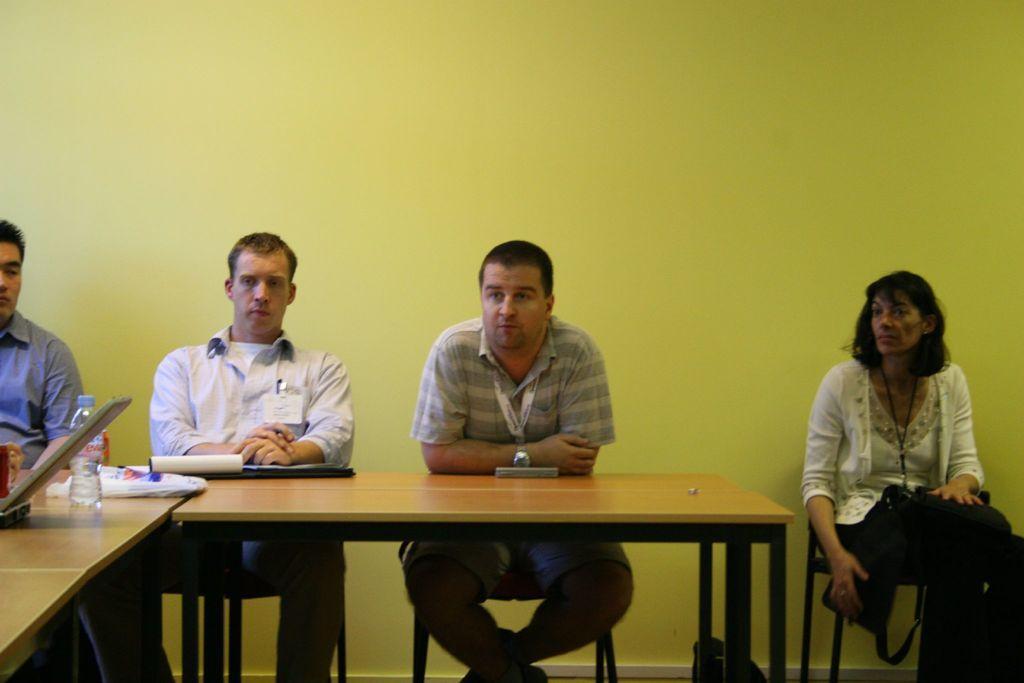Could you give a brief overview of what you see in this image? This picture is clicked inside the room. There are four people sitting on the chair. On the right corner of the picture, we see women wearing white dress is is holding black back in her hands. In the middle of the picture, we see a man in grey t-shirt is wearing ID card, he is also wearing watch. The man on the left corner of the picture is wearing blue shirt. In front of them, we see a table on which laptop, cover, water bottle is placed. 